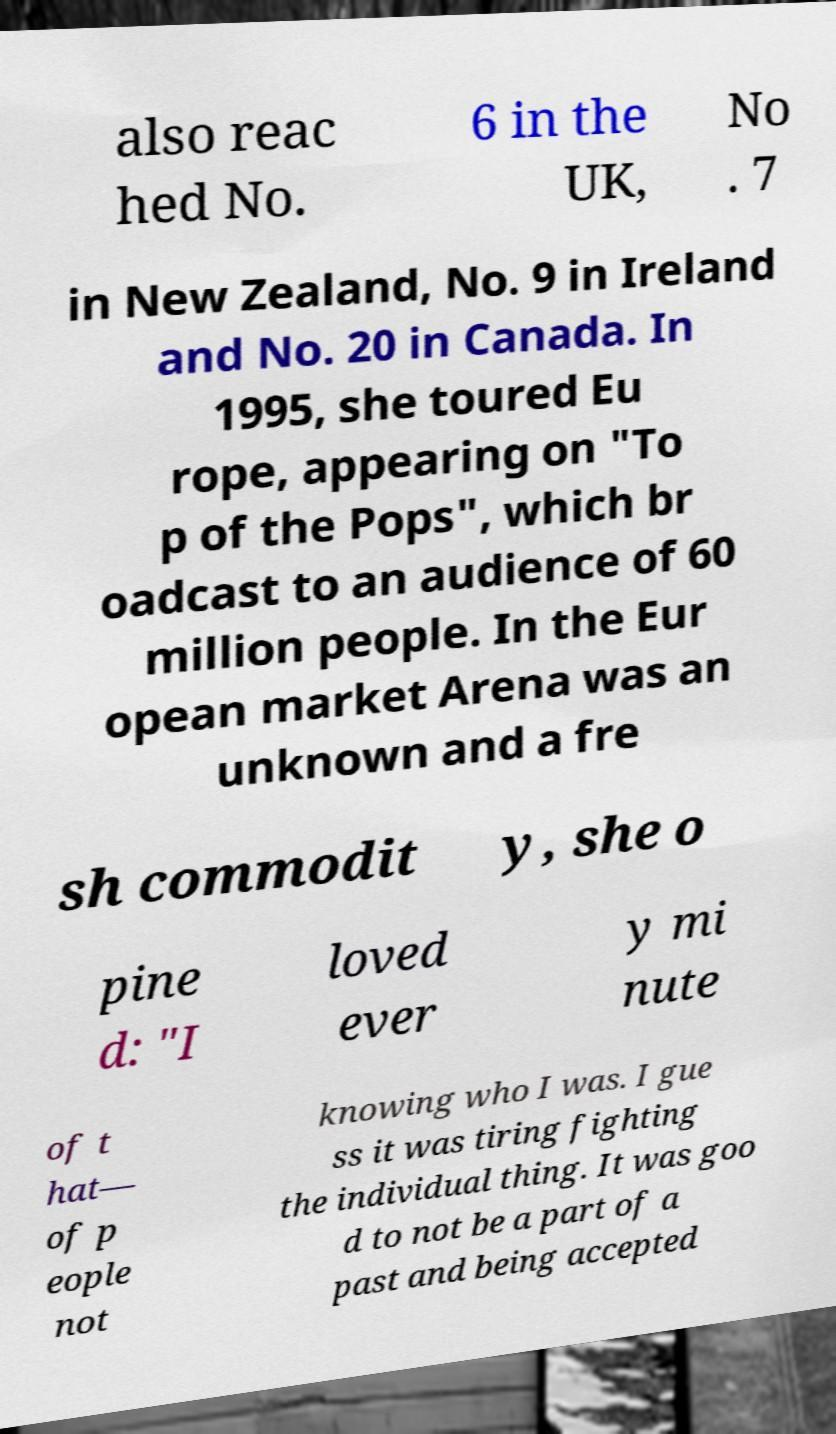Can you accurately transcribe the text from the provided image for me? also reac hed No. 6 in the UK, No . 7 in New Zealand, No. 9 in Ireland and No. 20 in Canada. In 1995, she toured Eu rope, appearing on "To p of the Pops", which br oadcast to an audience of 60 million people. In the Eur opean market Arena was an unknown and a fre sh commodit y, she o pine d: "I loved ever y mi nute of t hat— of p eople not knowing who I was. I gue ss it was tiring fighting the individual thing. It was goo d to not be a part of a past and being accepted 